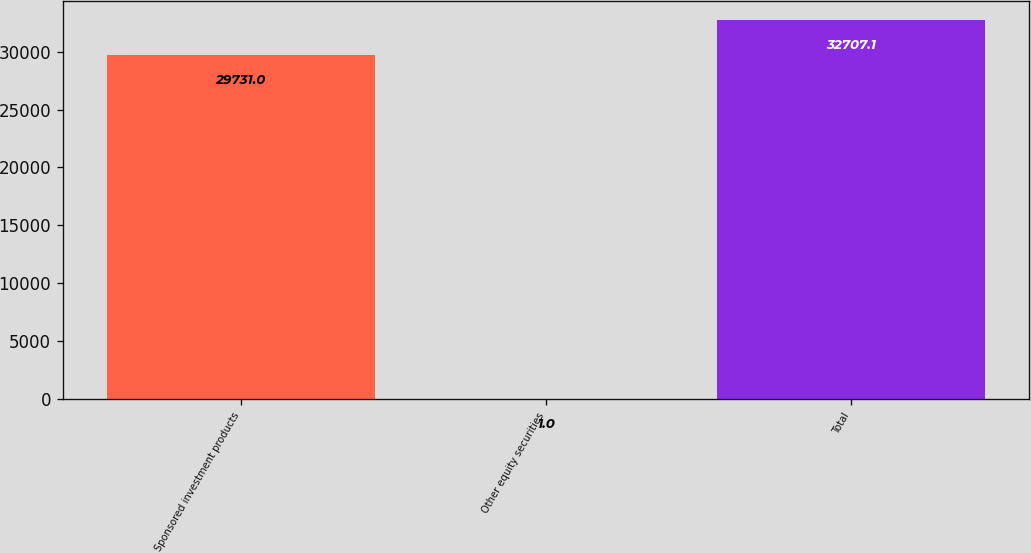<chart> <loc_0><loc_0><loc_500><loc_500><bar_chart><fcel>Sponsored investment products<fcel>Other equity securities<fcel>Total<nl><fcel>29731<fcel>1<fcel>32707.1<nl></chart> 